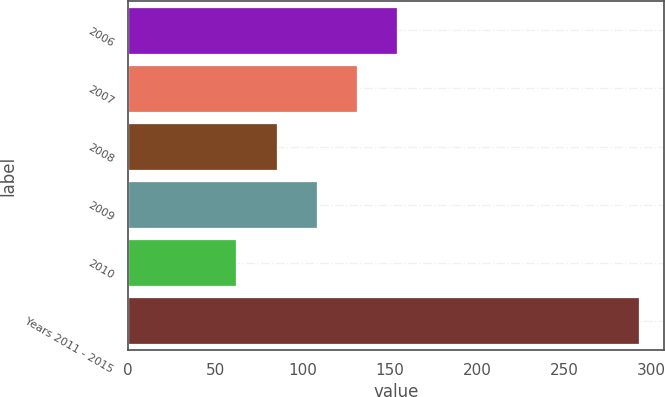<chart> <loc_0><loc_0><loc_500><loc_500><bar_chart><fcel>2006<fcel>2007<fcel>2008<fcel>2009<fcel>2010<fcel>Years 2011 - 2015<nl><fcel>154.4<fcel>131.3<fcel>85.1<fcel>108.2<fcel>62<fcel>293<nl></chart> 